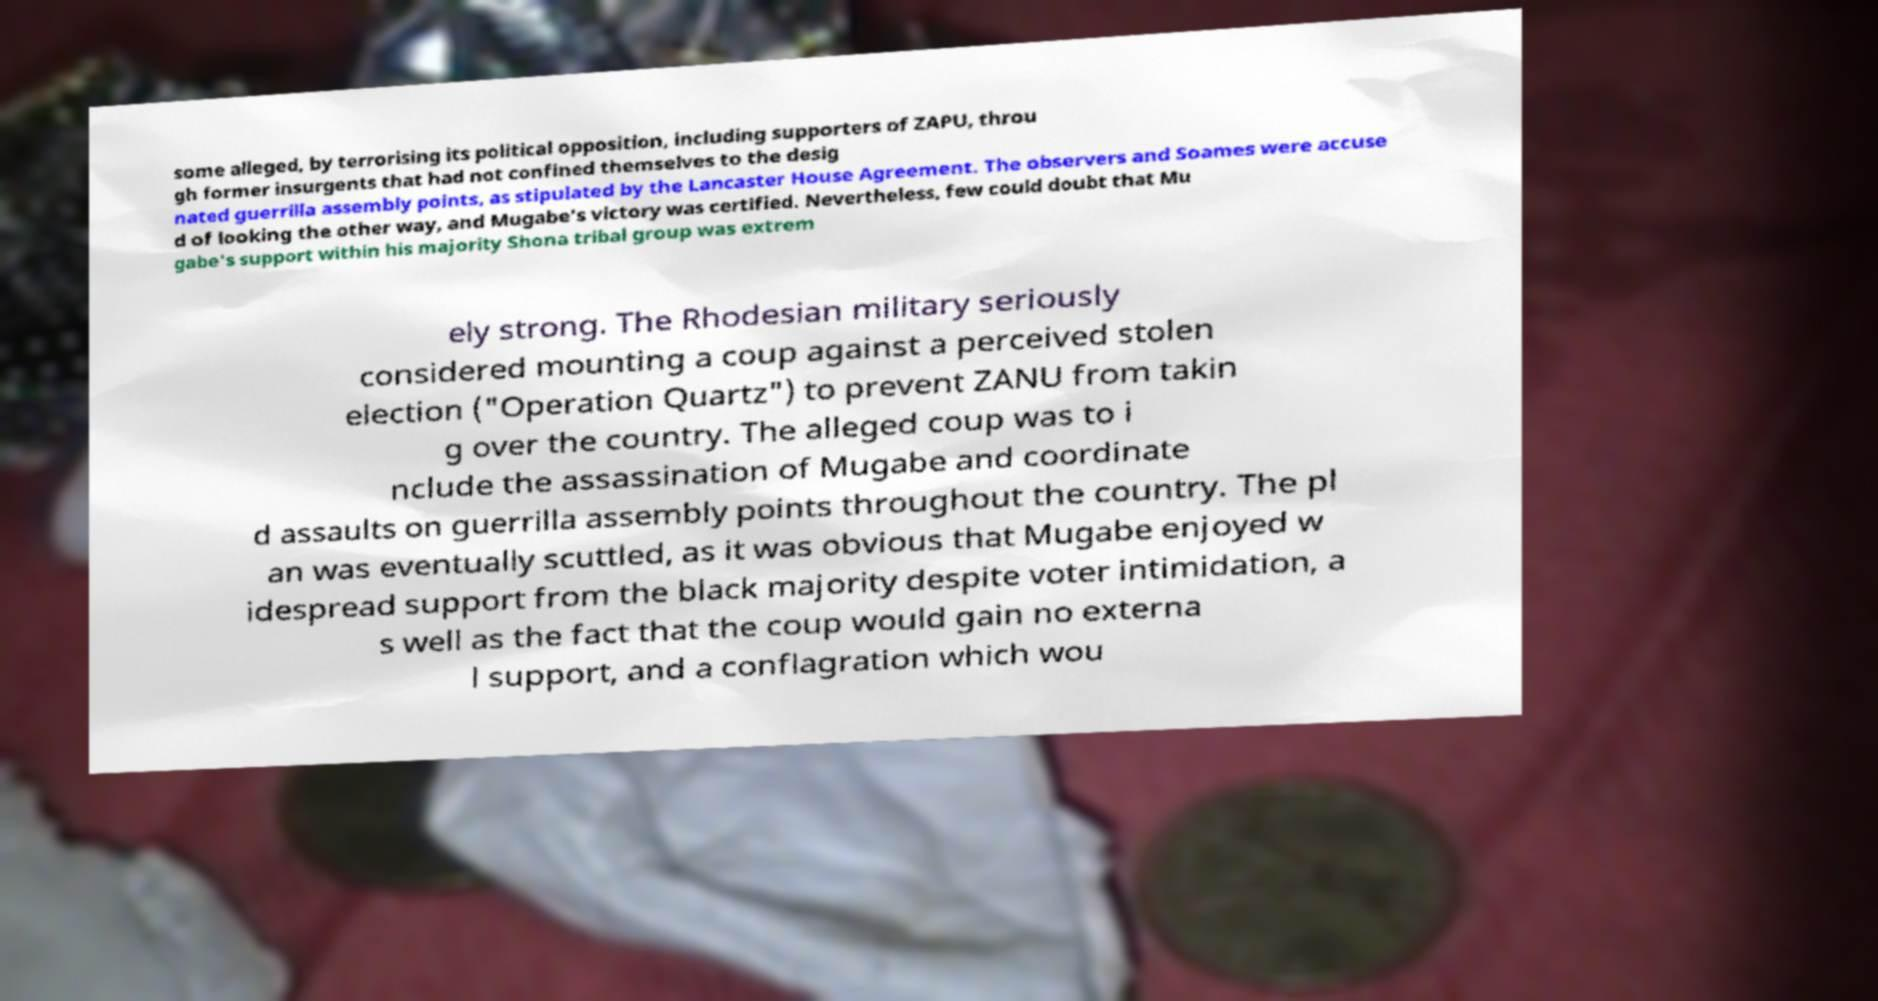Can you read and provide the text displayed in the image?This photo seems to have some interesting text. Can you extract and type it out for me? some alleged, by terrorising its political opposition, including supporters of ZAPU, throu gh former insurgents that had not confined themselves to the desig nated guerrilla assembly points, as stipulated by the Lancaster House Agreement. The observers and Soames were accuse d of looking the other way, and Mugabe's victory was certified. Nevertheless, few could doubt that Mu gabe's support within his majority Shona tribal group was extrem ely strong. The Rhodesian military seriously considered mounting a coup against a perceived stolen election ("Operation Quartz") to prevent ZANU from takin g over the country. The alleged coup was to i nclude the assassination of Mugabe and coordinate d assaults on guerrilla assembly points throughout the country. The pl an was eventually scuttled, as it was obvious that Mugabe enjoyed w idespread support from the black majority despite voter intimidation, a s well as the fact that the coup would gain no externa l support, and a conflagration which wou 